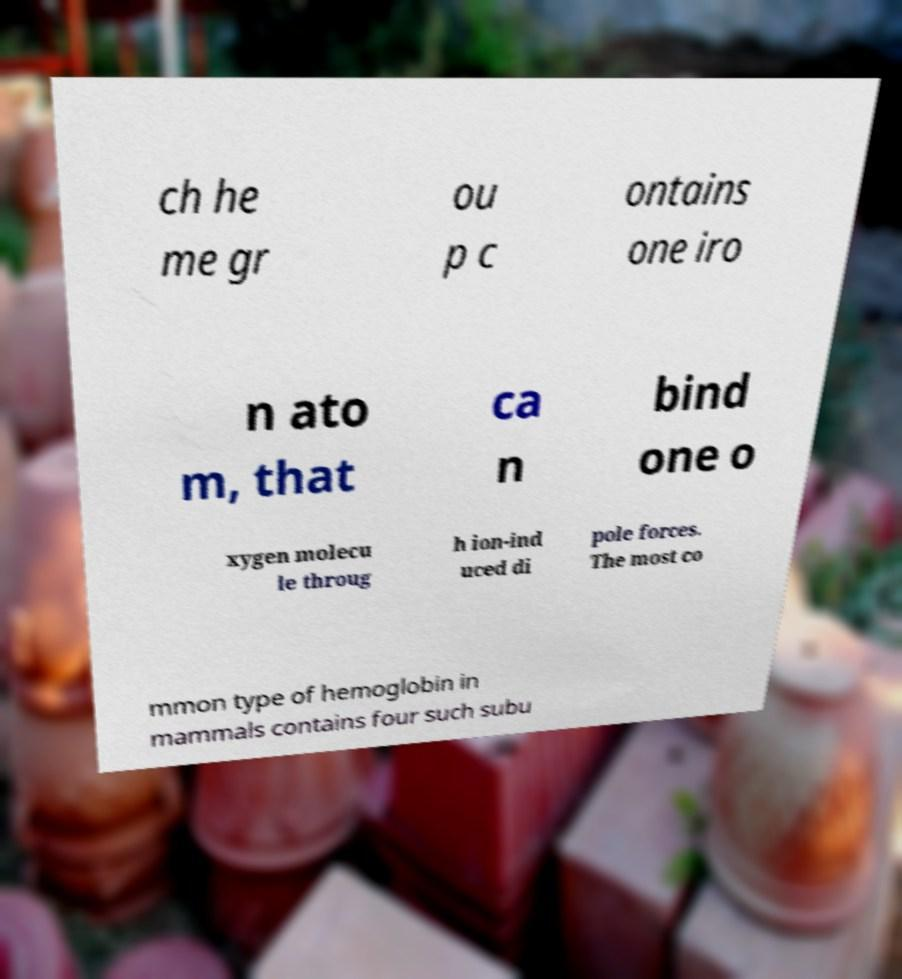I need the written content from this picture converted into text. Can you do that? ch he me gr ou p c ontains one iro n ato m, that ca n bind one o xygen molecu le throug h ion-ind uced di pole forces. The most co mmon type of hemoglobin in mammals contains four such subu 